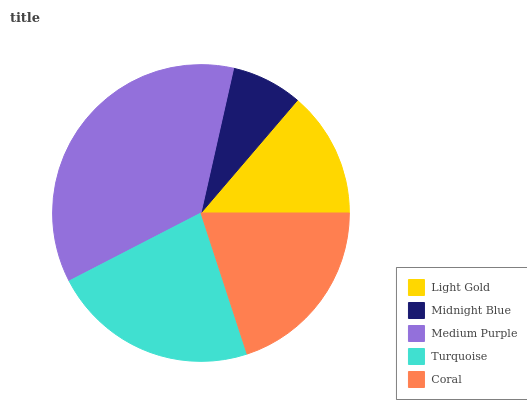Is Midnight Blue the minimum?
Answer yes or no. Yes. Is Medium Purple the maximum?
Answer yes or no. Yes. Is Medium Purple the minimum?
Answer yes or no. No. Is Midnight Blue the maximum?
Answer yes or no. No. Is Medium Purple greater than Midnight Blue?
Answer yes or no. Yes. Is Midnight Blue less than Medium Purple?
Answer yes or no. Yes. Is Midnight Blue greater than Medium Purple?
Answer yes or no. No. Is Medium Purple less than Midnight Blue?
Answer yes or no. No. Is Coral the high median?
Answer yes or no. Yes. Is Coral the low median?
Answer yes or no. Yes. Is Light Gold the high median?
Answer yes or no. No. Is Medium Purple the low median?
Answer yes or no. No. 